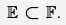<formula> <loc_0><loc_0><loc_500><loc_500>\mathbb { E } \subset \mathbb { F } .</formula> 